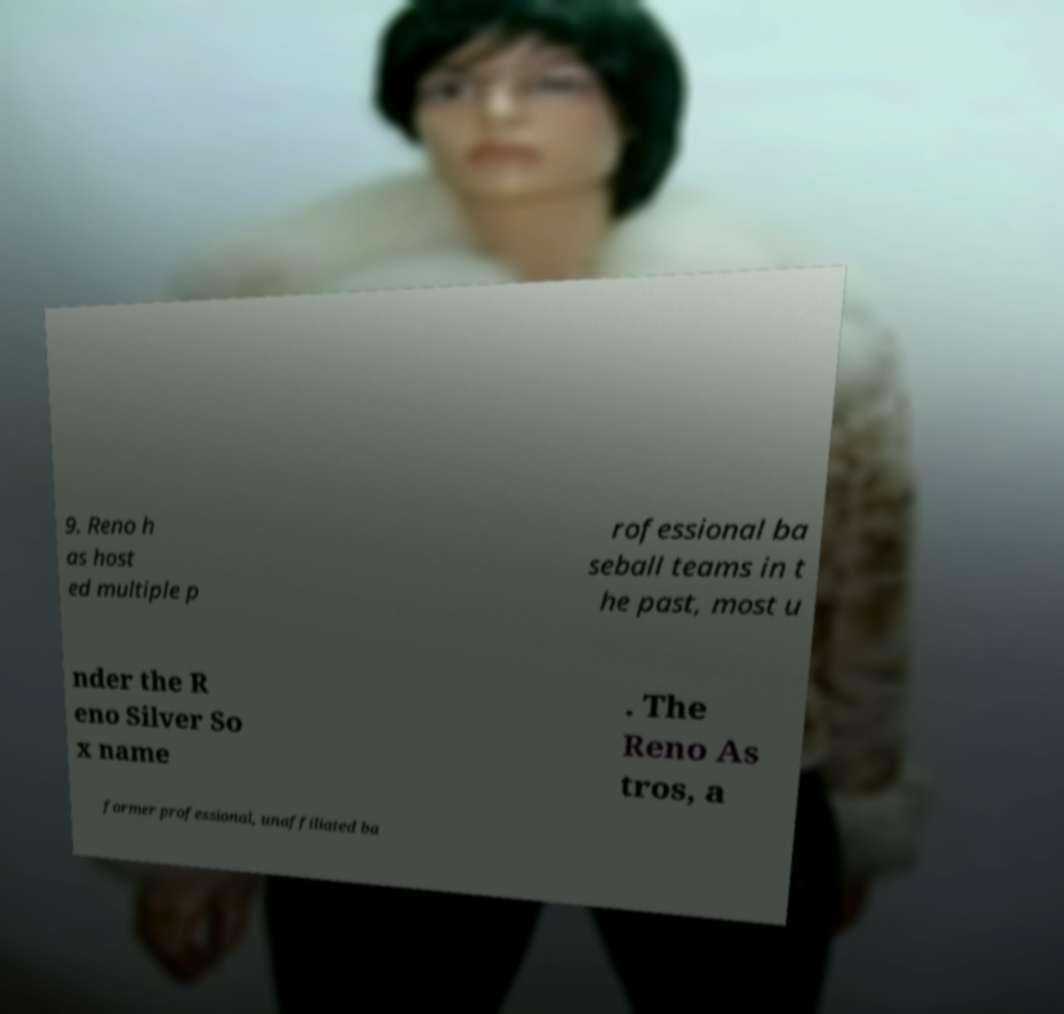I need the written content from this picture converted into text. Can you do that? 9. Reno h as host ed multiple p rofessional ba seball teams in t he past, most u nder the R eno Silver So x name . The Reno As tros, a former professional, unaffiliated ba 